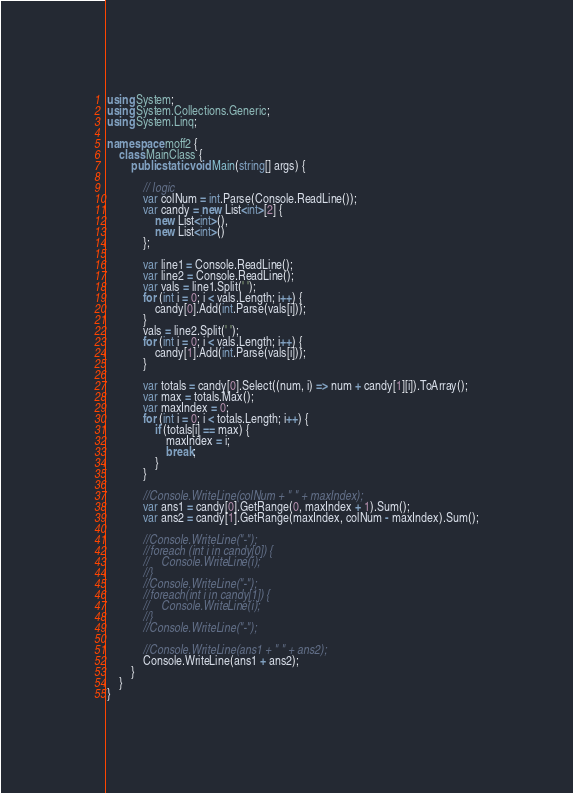Convert code to text. <code><loc_0><loc_0><loc_500><loc_500><_C#_>using System;
using System.Collections.Generic;
using System.Linq;

namespace moff2 {
    class MainClass {
        public static void Main(string[] args) {

            // logic
            var colNum = int.Parse(Console.ReadLine());
            var candy = new List<int>[2] {
                new List<int>(),
                new List<int>()
            };

            var line1 = Console.ReadLine();
            var line2 = Console.ReadLine();
            var vals = line1.Split(' ');
            for (int i = 0; i < vals.Length; i++) {
                candy[0].Add(int.Parse(vals[i]));
            }
            vals = line2.Split(' ');
            for (int i = 0; i < vals.Length; i++) {
                candy[1].Add(int.Parse(vals[i]));
            }

            var totals = candy[0].Select((num, i) => num + candy[1][i]).ToArray();
            var max = totals.Max();
            var maxIndex = 0;
            for (int i = 0; i < totals.Length; i++) {
                if (totals[i] == max) {
                    maxIndex = i;
                    break;
                }
            }

            //Console.WriteLine(colNum + " " + maxIndex);
            var ans1 = candy[0].GetRange(0, maxIndex + 1).Sum();
            var ans2 = candy[1].GetRange(maxIndex, colNum - maxIndex).Sum();

            //Console.WriteLine("-");
            //foreach (int i in candy[0]) {
            //    Console.WriteLine(i);
            //}
            //Console.WriteLine("-");
            //foreach(int i in candy[1]) {
            //    Console.WriteLine(i);
            //}
            //Console.WriteLine("-");

            //Console.WriteLine(ans1 + " " + ans2);
            Console.WriteLine(ans1 + ans2);
        }
    }
}
</code> 